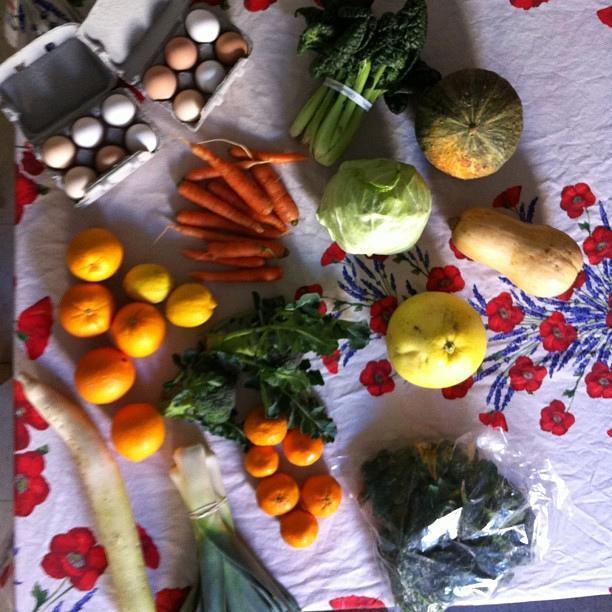How many broccolis are in the picture?
Give a very brief answer. 3. How many oranges are there?
Give a very brief answer. 2. 